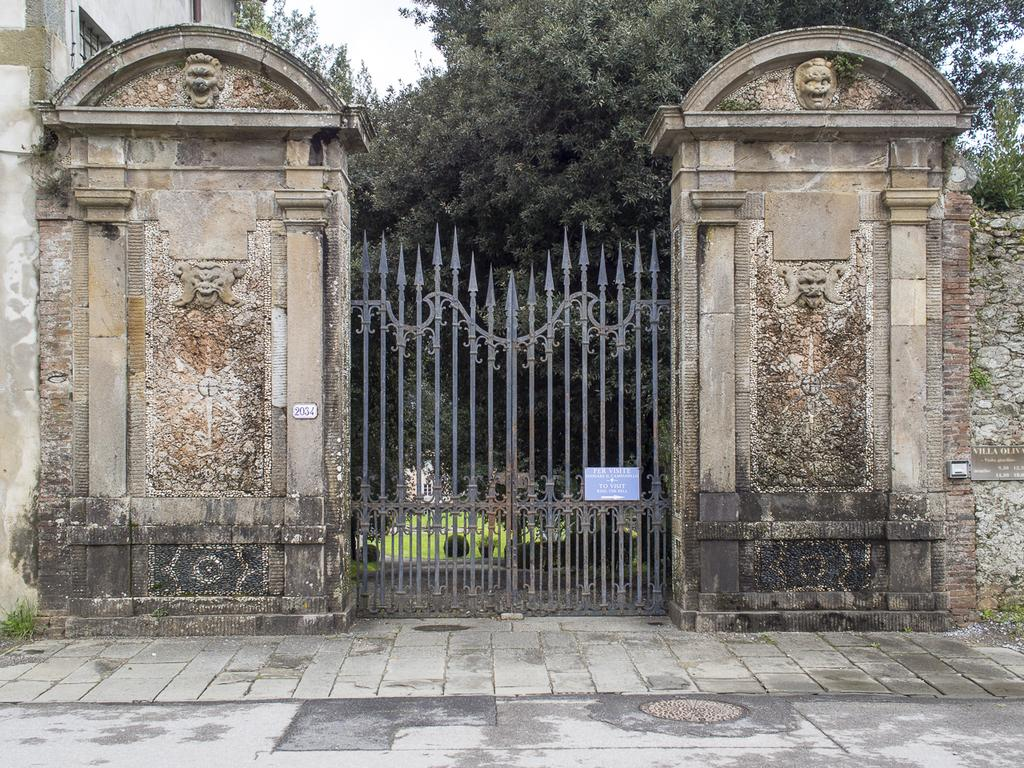What type of barrier is present in the image? There is an iron gate in the image. What other structures can be seen in the image? There are walls in the image. What is located behind the iron gate? Trees are visible behind the iron gate. What part of the natural environment is visible in the image? The sky is visible in the image. What type of collar can be seen on the island in the image? There is no collar or island present in the image. 